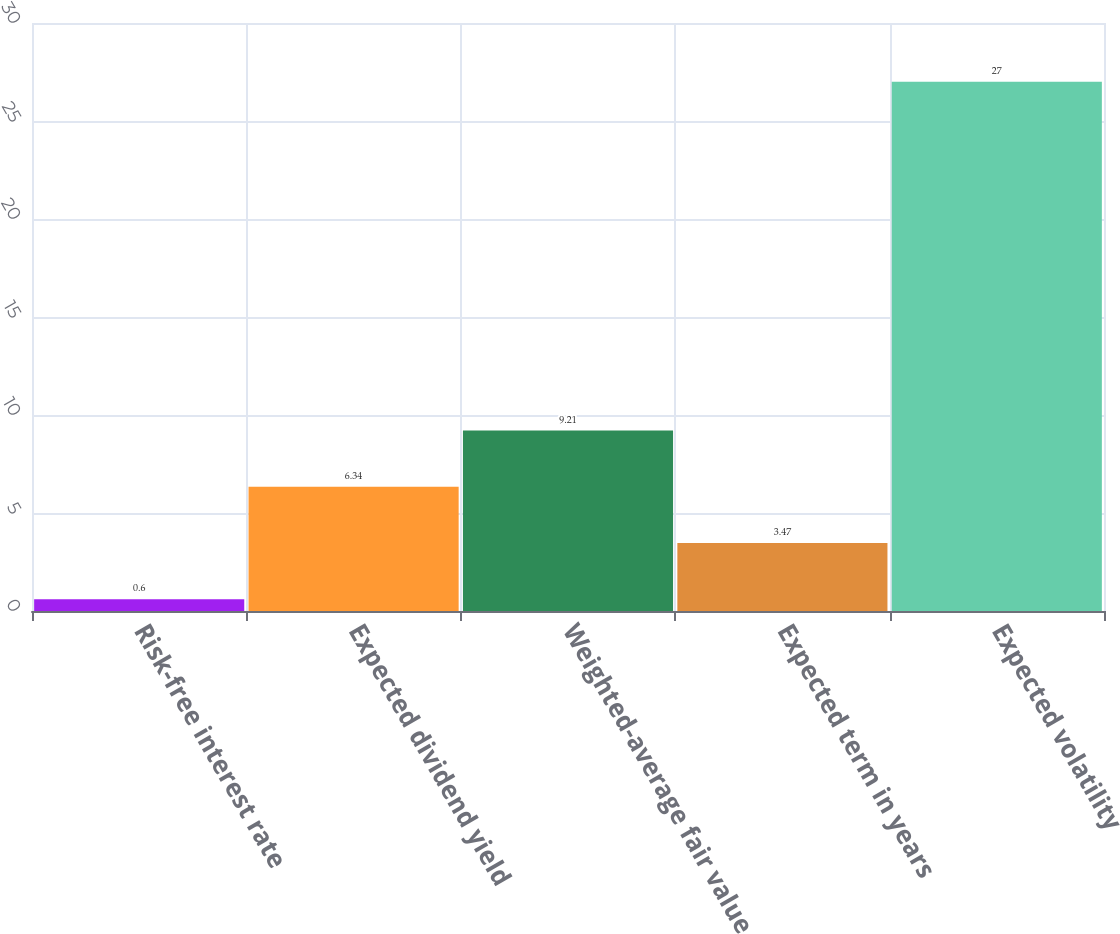Convert chart. <chart><loc_0><loc_0><loc_500><loc_500><bar_chart><fcel>Risk-free interest rate<fcel>Expected dividend yield<fcel>Weighted-average fair value<fcel>Expected term in years<fcel>Expected volatility<nl><fcel>0.6<fcel>6.34<fcel>9.21<fcel>3.47<fcel>27<nl></chart> 